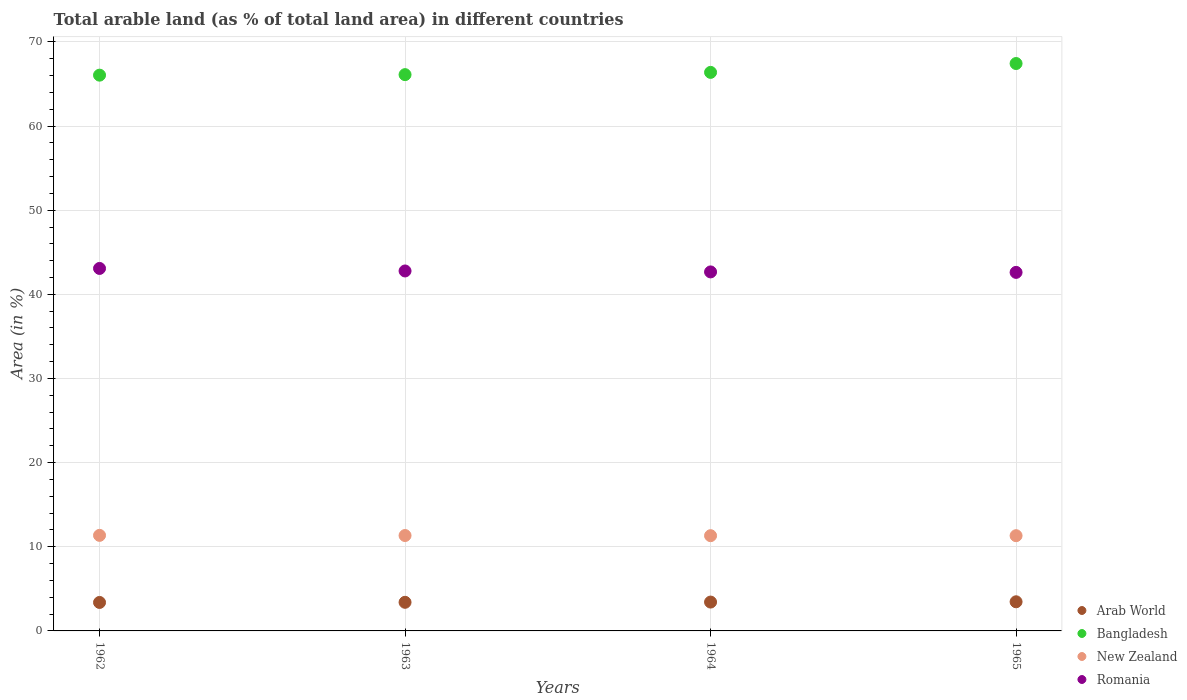Is the number of dotlines equal to the number of legend labels?
Your response must be concise. Yes. What is the percentage of arable land in Romania in 1963?
Your response must be concise. 42.78. Across all years, what is the maximum percentage of arable land in New Zealand?
Provide a succinct answer. 11.36. Across all years, what is the minimum percentage of arable land in New Zealand?
Provide a succinct answer. 11.32. In which year was the percentage of arable land in Bangladesh maximum?
Keep it short and to the point. 1965. In which year was the percentage of arable land in Romania minimum?
Ensure brevity in your answer.  1965. What is the total percentage of arable land in Bangladesh in the graph?
Give a very brief answer. 265.95. What is the difference between the percentage of arable land in New Zealand in 1962 and that in 1965?
Your answer should be compact. 0.04. What is the difference between the percentage of arable land in Bangladesh in 1962 and the percentage of arable land in Romania in 1965?
Your answer should be very brief. 23.44. What is the average percentage of arable land in Romania per year?
Your response must be concise. 42.78. In the year 1965, what is the difference between the percentage of arable land in Romania and percentage of arable land in Arab World?
Your response must be concise. 39.14. What is the ratio of the percentage of arable land in Romania in 1962 to that in 1965?
Provide a succinct answer. 1.01. Is the difference between the percentage of arable land in Romania in 1962 and 1965 greater than the difference between the percentage of arable land in Arab World in 1962 and 1965?
Give a very brief answer. Yes. What is the difference between the highest and the second highest percentage of arable land in Arab World?
Provide a short and direct response. 0.03. What is the difference between the highest and the lowest percentage of arable land in Bangladesh?
Provide a short and direct response. 1.38. In how many years, is the percentage of arable land in Bangladesh greater than the average percentage of arable land in Bangladesh taken over all years?
Offer a terse response. 1. Is it the case that in every year, the sum of the percentage of arable land in Romania and percentage of arable land in Bangladesh  is greater than the sum of percentage of arable land in Arab World and percentage of arable land in New Zealand?
Your response must be concise. Yes. Is it the case that in every year, the sum of the percentage of arable land in Bangladesh and percentage of arable land in Romania  is greater than the percentage of arable land in New Zealand?
Offer a very short reply. Yes. Does the percentage of arable land in Arab World monotonically increase over the years?
Make the answer very short. Yes. Is the percentage of arable land in Arab World strictly greater than the percentage of arable land in Romania over the years?
Provide a short and direct response. No. Is the percentage of arable land in New Zealand strictly less than the percentage of arable land in Romania over the years?
Make the answer very short. Yes. Does the graph contain grids?
Provide a short and direct response. Yes. How many legend labels are there?
Ensure brevity in your answer.  4. How are the legend labels stacked?
Give a very brief answer. Vertical. What is the title of the graph?
Offer a terse response. Total arable land (as % of total land area) in different countries. Does "Chile" appear as one of the legend labels in the graph?
Make the answer very short. No. What is the label or title of the Y-axis?
Make the answer very short. Area (in %). What is the Area (in %) in Arab World in 1962?
Provide a short and direct response. 3.38. What is the Area (in %) of Bangladesh in 1962?
Ensure brevity in your answer.  66.04. What is the Area (in %) in New Zealand in 1962?
Offer a terse response. 11.36. What is the Area (in %) of Romania in 1962?
Keep it short and to the point. 43.08. What is the Area (in %) in Arab World in 1963?
Provide a succinct answer. 3.4. What is the Area (in %) in Bangladesh in 1963?
Give a very brief answer. 66.11. What is the Area (in %) in New Zealand in 1963?
Keep it short and to the point. 11.34. What is the Area (in %) in Romania in 1963?
Provide a short and direct response. 42.78. What is the Area (in %) in Arab World in 1964?
Your answer should be very brief. 3.43. What is the Area (in %) in Bangladesh in 1964?
Your answer should be very brief. 66.37. What is the Area (in %) in New Zealand in 1964?
Your answer should be very brief. 11.32. What is the Area (in %) of Romania in 1964?
Make the answer very short. 42.66. What is the Area (in %) of Arab World in 1965?
Keep it short and to the point. 3.46. What is the Area (in %) of Bangladesh in 1965?
Ensure brevity in your answer.  67.43. What is the Area (in %) in New Zealand in 1965?
Provide a short and direct response. 11.32. What is the Area (in %) of Romania in 1965?
Keep it short and to the point. 42.61. Across all years, what is the maximum Area (in %) of Arab World?
Your answer should be very brief. 3.46. Across all years, what is the maximum Area (in %) of Bangladesh?
Provide a succinct answer. 67.43. Across all years, what is the maximum Area (in %) in New Zealand?
Your response must be concise. 11.36. Across all years, what is the maximum Area (in %) of Romania?
Provide a succinct answer. 43.08. Across all years, what is the minimum Area (in %) of Arab World?
Your response must be concise. 3.38. Across all years, what is the minimum Area (in %) of Bangladesh?
Provide a succinct answer. 66.04. Across all years, what is the minimum Area (in %) of New Zealand?
Offer a terse response. 11.32. Across all years, what is the minimum Area (in %) in Romania?
Your answer should be compact. 42.61. What is the total Area (in %) in Arab World in the graph?
Give a very brief answer. 13.67. What is the total Area (in %) of Bangladesh in the graph?
Provide a short and direct response. 265.95. What is the total Area (in %) in New Zealand in the graph?
Offer a very short reply. 45.33. What is the total Area (in %) in Romania in the graph?
Give a very brief answer. 171.12. What is the difference between the Area (in %) of Arab World in 1962 and that in 1963?
Give a very brief answer. -0.02. What is the difference between the Area (in %) in Bangladesh in 1962 and that in 1963?
Give a very brief answer. -0.06. What is the difference between the Area (in %) of New Zealand in 1962 and that in 1963?
Offer a very short reply. 0.02. What is the difference between the Area (in %) in Romania in 1962 and that in 1963?
Offer a very short reply. 0.3. What is the difference between the Area (in %) in Arab World in 1962 and that in 1964?
Your answer should be very brief. -0.04. What is the difference between the Area (in %) of Bangladesh in 1962 and that in 1964?
Your answer should be very brief. -0.33. What is the difference between the Area (in %) in New Zealand in 1962 and that in 1964?
Your answer should be compact. 0.04. What is the difference between the Area (in %) of Romania in 1962 and that in 1964?
Provide a short and direct response. 0.41. What is the difference between the Area (in %) in Arab World in 1962 and that in 1965?
Give a very brief answer. -0.08. What is the difference between the Area (in %) in Bangladesh in 1962 and that in 1965?
Keep it short and to the point. -1.38. What is the difference between the Area (in %) in New Zealand in 1962 and that in 1965?
Provide a short and direct response. 0.04. What is the difference between the Area (in %) of Romania in 1962 and that in 1965?
Your answer should be very brief. 0.47. What is the difference between the Area (in %) of Arab World in 1963 and that in 1964?
Give a very brief answer. -0.03. What is the difference between the Area (in %) in Bangladesh in 1963 and that in 1964?
Provide a short and direct response. -0.27. What is the difference between the Area (in %) of New Zealand in 1963 and that in 1964?
Provide a short and direct response. 0.02. What is the difference between the Area (in %) in Romania in 1963 and that in 1964?
Offer a very short reply. 0.11. What is the difference between the Area (in %) in Arab World in 1963 and that in 1965?
Offer a terse response. -0.06. What is the difference between the Area (in %) of Bangladesh in 1963 and that in 1965?
Offer a very short reply. -1.32. What is the difference between the Area (in %) in New Zealand in 1963 and that in 1965?
Your response must be concise. 0.02. What is the difference between the Area (in %) of Romania in 1963 and that in 1965?
Provide a succinct answer. 0.17. What is the difference between the Area (in %) of Arab World in 1964 and that in 1965?
Provide a short and direct response. -0.03. What is the difference between the Area (in %) in Bangladesh in 1964 and that in 1965?
Keep it short and to the point. -1.05. What is the difference between the Area (in %) of New Zealand in 1964 and that in 1965?
Make the answer very short. 0. What is the difference between the Area (in %) of Romania in 1964 and that in 1965?
Make the answer very short. 0.06. What is the difference between the Area (in %) of Arab World in 1962 and the Area (in %) of Bangladesh in 1963?
Your answer should be compact. -62.72. What is the difference between the Area (in %) of Arab World in 1962 and the Area (in %) of New Zealand in 1963?
Your response must be concise. -7.95. What is the difference between the Area (in %) in Arab World in 1962 and the Area (in %) in Romania in 1963?
Provide a short and direct response. -39.39. What is the difference between the Area (in %) in Bangladesh in 1962 and the Area (in %) in New Zealand in 1963?
Provide a succinct answer. 54.71. What is the difference between the Area (in %) of Bangladesh in 1962 and the Area (in %) of Romania in 1963?
Your response must be concise. 23.27. What is the difference between the Area (in %) of New Zealand in 1962 and the Area (in %) of Romania in 1963?
Make the answer very short. -31.42. What is the difference between the Area (in %) of Arab World in 1962 and the Area (in %) of Bangladesh in 1964?
Your response must be concise. -62.99. What is the difference between the Area (in %) of Arab World in 1962 and the Area (in %) of New Zealand in 1964?
Make the answer very short. -7.93. What is the difference between the Area (in %) in Arab World in 1962 and the Area (in %) in Romania in 1964?
Provide a succinct answer. -39.28. What is the difference between the Area (in %) in Bangladesh in 1962 and the Area (in %) in New Zealand in 1964?
Offer a very short reply. 54.73. What is the difference between the Area (in %) of Bangladesh in 1962 and the Area (in %) of Romania in 1964?
Offer a very short reply. 23.38. What is the difference between the Area (in %) of New Zealand in 1962 and the Area (in %) of Romania in 1964?
Your answer should be compact. -31.31. What is the difference between the Area (in %) of Arab World in 1962 and the Area (in %) of Bangladesh in 1965?
Offer a terse response. -64.04. What is the difference between the Area (in %) in Arab World in 1962 and the Area (in %) in New Zealand in 1965?
Provide a succinct answer. -7.93. What is the difference between the Area (in %) in Arab World in 1962 and the Area (in %) in Romania in 1965?
Make the answer very short. -39.22. What is the difference between the Area (in %) in Bangladesh in 1962 and the Area (in %) in New Zealand in 1965?
Make the answer very short. 54.73. What is the difference between the Area (in %) in Bangladesh in 1962 and the Area (in %) in Romania in 1965?
Offer a very short reply. 23.44. What is the difference between the Area (in %) in New Zealand in 1962 and the Area (in %) in Romania in 1965?
Your response must be concise. -31.25. What is the difference between the Area (in %) of Arab World in 1963 and the Area (in %) of Bangladesh in 1964?
Your answer should be very brief. -62.97. What is the difference between the Area (in %) of Arab World in 1963 and the Area (in %) of New Zealand in 1964?
Give a very brief answer. -7.92. What is the difference between the Area (in %) in Arab World in 1963 and the Area (in %) in Romania in 1964?
Offer a very short reply. -39.26. What is the difference between the Area (in %) in Bangladesh in 1963 and the Area (in %) in New Zealand in 1964?
Keep it short and to the point. 54.79. What is the difference between the Area (in %) in Bangladesh in 1963 and the Area (in %) in Romania in 1964?
Give a very brief answer. 23.44. What is the difference between the Area (in %) of New Zealand in 1963 and the Area (in %) of Romania in 1964?
Ensure brevity in your answer.  -31.33. What is the difference between the Area (in %) in Arab World in 1963 and the Area (in %) in Bangladesh in 1965?
Keep it short and to the point. -64.03. What is the difference between the Area (in %) of Arab World in 1963 and the Area (in %) of New Zealand in 1965?
Your response must be concise. -7.92. What is the difference between the Area (in %) of Arab World in 1963 and the Area (in %) of Romania in 1965?
Give a very brief answer. -39.21. What is the difference between the Area (in %) in Bangladesh in 1963 and the Area (in %) in New Zealand in 1965?
Offer a terse response. 54.79. What is the difference between the Area (in %) in Bangladesh in 1963 and the Area (in %) in Romania in 1965?
Offer a very short reply. 23.5. What is the difference between the Area (in %) of New Zealand in 1963 and the Area (in %) of Romania in 1965?
Your response must be concise. -31.27. What is the difference between the Area (in %) of Arab World in 1964 and the Area (in %) of Bangladesh in 1965?
Your answer should be compact. -64. What is the difference between the Area (in %) of Arab World in 1964 and the Area (in %) of New Zealand in 1965?
Provide a short and direct response. -7.89. What is the difference between the Area (in %) in Arab World in 1964 and the Area (in %) in Romania in 1965?
Ensure brevity in your answer.  -39.18. What is the difference between the Area (in %) of Bangladesh in 1964 and the Area (in %) of New Zealand in 1965?
Keep it short and to the point. 55.06. What is the difference between the Area (in %) of Bangladesh in 1964 and the Area (in %) of Romania in 1965?
Provide a succinct answer. 23.77. What is the difference between the Area (in %) in New Zealand in 1964 and the Area (in %) in Romania in 1965?
Provide a succinct answer. -31.29. What is the average Area (in %) in Arab World per year?
Your answer should be compact. 3.42. What is the average Area (in %) in Bangladesh per year?
Offer a terse response. 66.49. What is the average Area (in %) of New Zealand per year?
Offer a very short reply. 11.33. What is the average Area (in %) in Romania per year?
Keep it short and to the point. 42.78. In the year 1962, what is the difference between the Area (in %) in Arab World and Area (in %) in Bangladesh?
Provide a succinct answer. -62.66. In the year 1962, what is the difference between the Area (in %) of Arab World and Area (in %) of New Zealand?
Keep it short and to the point. -7.97. In the year 1962, what is the difference between the Area (in %) of Arab World and Area (in %) of Romania?
Provide a succinct answer. -39.69. In the year 1962, what is the difference between the Area (in %) of Bangladesh and Area (in %) of New Zealand?
Offer a terse response. 54.69. In the year 1962, what is the difference between the Area (in %) in Bangladesh and Area (in %) in Romania?
Your answer should be compact. 22.97. In the year 1962, what is the difference between the Area (in %) in New Zealand and Area (in %) in Romania?
Provide a succinct answer. -31.72. In the year 1963, what is the difference between the Area (in %) in Arab World and Area (in %) in Bangladesh?
Provide a succinct answer. -62.71. In the year 1963, what is the difference between the Area (in %) in Arab World and Area (in %) in New Zealand?
Keep it short and to the point. -7.94. In the year 1963, what is the difference between the Area (in %) in Arab World and Area (in %) in Romania?
Offer a very short reply. -39.38. In the year 1963, what is the difference between the Area (in %) of Bangladesh and Area (in %) of New Zealand?
Provide a succinct answer. 54.77. In the year 1963, what is the difference between the Area (in %) of Bangladesh and Area (in %) of Romania?
Keep it short and to the point. 23.33. In the year 1963, what is the difference between the Area (in %) in New Zealand and Area (in %) in Romania?
Make the answer very short. -31.44. In the year 1964, what is the difference between the Area (in %) in Arab World and Area (in %) in Bangladesh?
Your answer should be compact. -62.95. In the year 1964, what is the difference between the Area (in %) of Arab World and Area (in %) of New Zealand?
Provide a short and direct response. -7.89. In the year 1964, what is the difference between the Area (in %) of Arab World and Area (in %) of Romania?
Offer a terse response. -39.23. In the year 1964, what is the difference between the Area (in %) in Bangladesh and Area (in %) in New Zealand?
Provide a succinct answer. 55.06. In the year 1964, what is the difference between the Area (in %) in Bangladesh and Area (in %) in Romania?
Your response must be concise. 23.71. In the year 1964, what is the difference between the Area (in %) in New Zealand and Area (in %) in Romania?
Your response must be concise. -31.35. In the year 1965, what is the difference between the Area (in %) in Arab World and Area (in %) in Bangladesh?
Your answer should be compact. -63.96. In the year 1965, what is the difference between the Area (in %) in Arab World and Area (in %) in New Zealand?
Provide a short and direct response. -7.86. In the year 1965, what is the difference between the Area (in %) of Arab World and Area (in %) of Romania?
Your answer should be very brief. -39.14. In the year 1965, what is the difference between the Area (in %) in Bangladesh and Area (in %) in New Zealand?
Ensure brevity in your answer.  56.11. In the year 1965, what is the difference between the Area (in %) of Bangladesh and Area (in %) of Romania?
Your response must be concise. 24.82. In the year 1965, what is the difference between the Area (in %) in New Zealand and Area (in %) in Romania?
Provide a short and direct response. -31.29. What is the ratio of the Area (in %) of Arab World in 1962 to that in 1963?
Ensure brevity in your answer.  1. What is the ratio of the Area (in %) in New Zealand in 1962 to that in 1963?
Keep it short and to the point. 1. What is the ratio of the Area (in %) of Romania in 1962 to that in 1963?
Ensure brevity in your answer.  1.01. What is the ratio of the Area (in %) of New Zealand in 1962 to that in 1964?
Your answer should be very brief. 1. What is the ratio of the Area (in %) of Romania in 1962 to that in 1964?
Keep it short and to the point. 1.01. What is the ratio of the Area (in %) of Arab World in 1962 to that in 1965?
Make the answer very short. 0.98. What is the ratio of the Area (in %) in Bangladesh in 1962 to that in 1965?
Offer a very short reply. 0.98. What is the ratio of the Area (in %) in New Zealand in 1962 to that in 1965?
Ensure brevity in your answer.  1. What is the ratio of the Area (in %) in Romania in 1962 to that in 1965?
Provide a succinct answer. 1.01. What is the ratio of the Area (in %) in Arab World in 1963 to that in 1965?
Make the answer very short. 0.98. What is the ratio of the Area (in %) of Bangladesh in 1963 to that in 1965?
Ensure brevity in your answer.  0.98. What is the ratio of the Area (in %) of Romania in 1963 to that in 1965?
Your answer should be very brief. 1. What is the ratio of the Area (in %) in Arab World in 1964 to that in 1965?
Offer a terse response. 0.99. What is the ratio of the Area (in %) of Bangladesh in 1964 to that in 1965?
Give a very brief answer. 0.98. What is the ratio of the Area (in %) of Romania in 1964 to that in 1965?
Offer a terse response. 1. What is the difference between the highest and the second highest Area (in %) of Arab World?
Your answer should be compact. 0.03. What is the difference between the highest and the second highest Area (in %) in Bangladesh?
Make the answer very short. 1.05. What is the difference between the highest and the second highest Area (in %) in New Zealand?
Your answer should be very brief. 0.02. What is the difference between the highest and the second highest Area (in %) in Romania?
Keep it short and to the point. 0.3. What is the difference between the highest and the lowest Area (in %) of Arab World?
Provide a short and direct response. 0.08. What is the difference between the highest and the lowest Area (in %) in Bangladesh?
Offer a terse response. 1.38. What is the difference between the highest and the lowest Area (in %) of New Zealand?
Your answer should be very brief. 0.04. What is the difference between the highest and the lowest Area (in %) in Romania?
Keep it short and to the point. 0.47. 